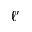Convert formula to latex. <formula><loc_0><loc_0><loc_500><loc_500>\ell ^ { \prime }</formula> 